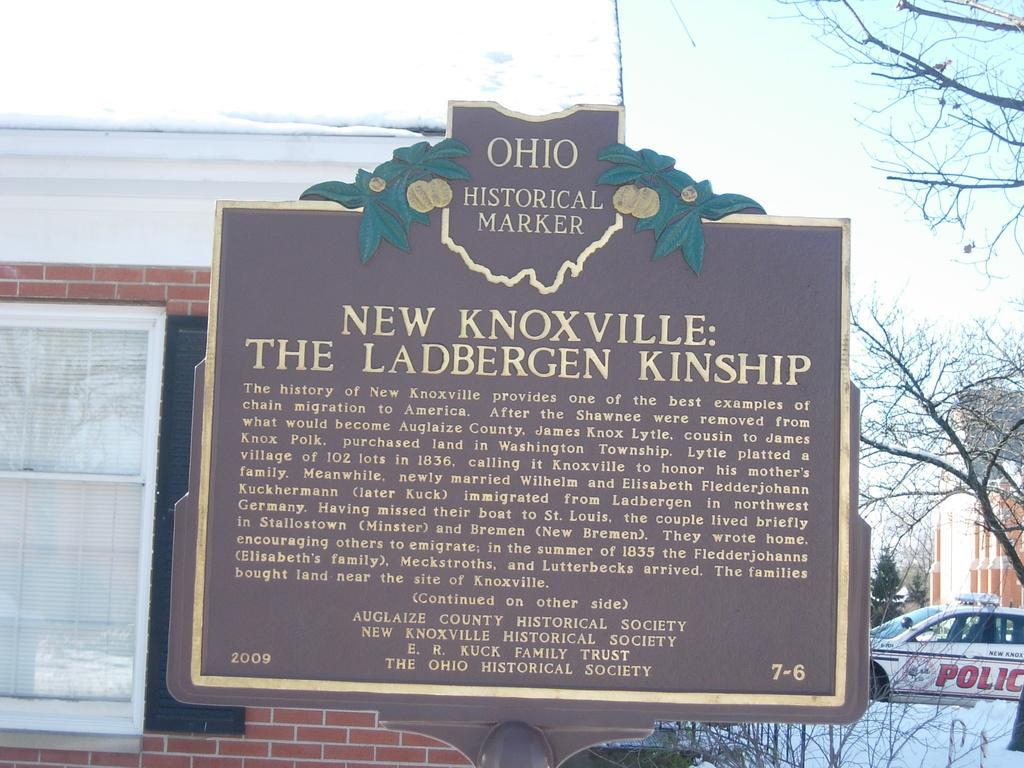What is located in the foreground of the image? There is a name board in the foreground of the image. What can be seen in the background of the image? There is a building, a window, a tree, a police car, and the sky visible in the background of the image. What type of advertisement is displayed on the hand in the image? There is no hand or advertisement present in the image. 